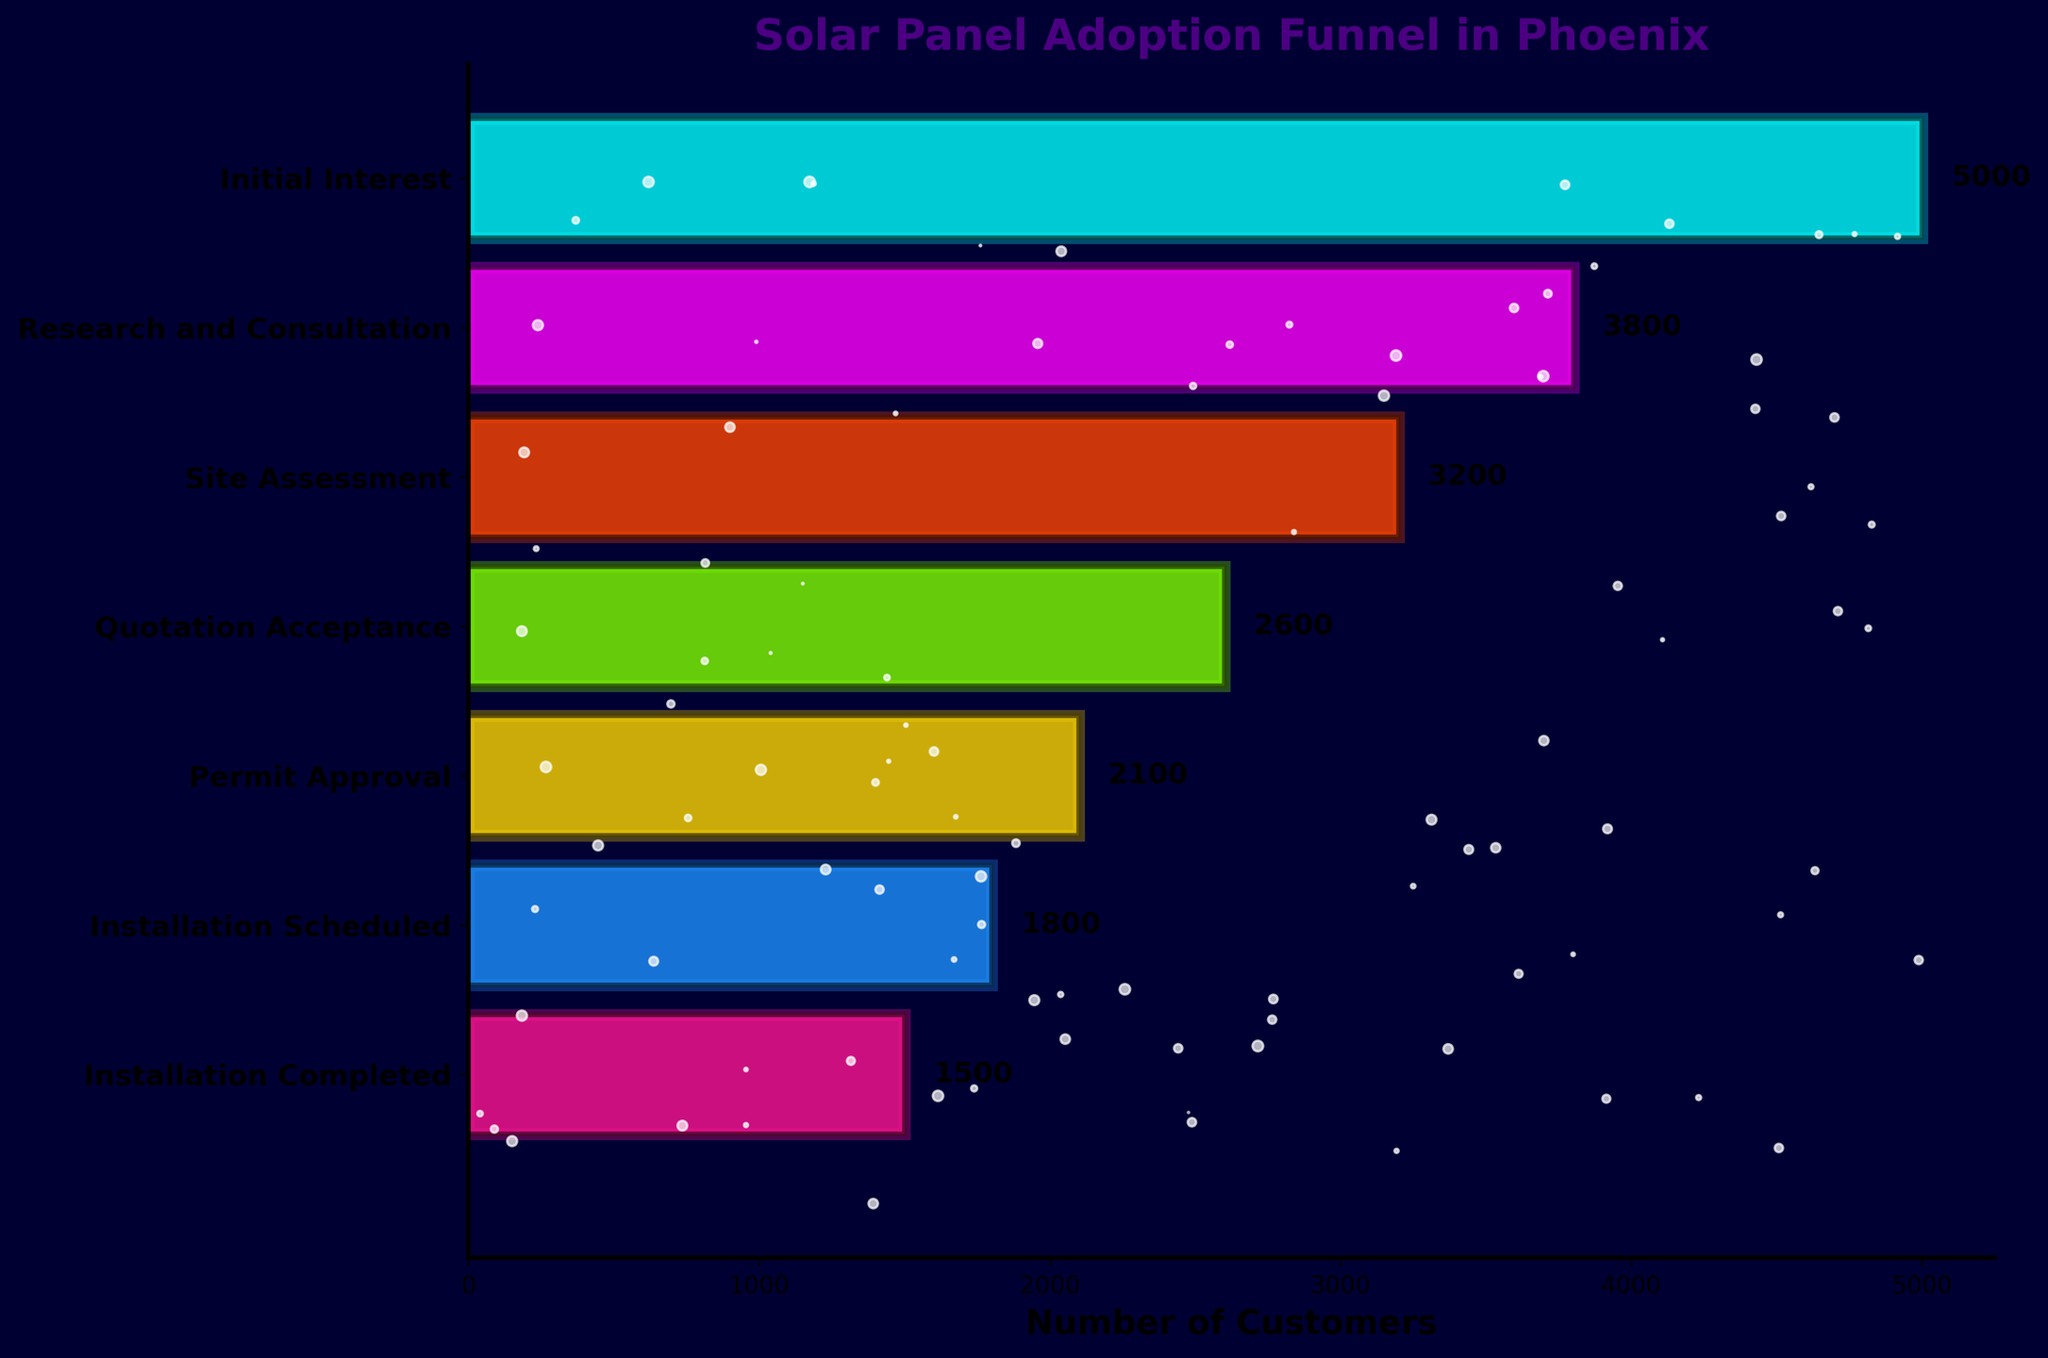What is the title of the chart? The title is located at the top of the chart and provides an overview of the data being represented.
Answer: Solar Panel Adoption Funnel in Phoenix How many stages are there in the funnel chart? Count the number of stages listed on the vertical axis from top to bottom.
Answer: 7 Which stage has the highest number of customers? Identify the longest bar, as it represents the highest count.
Answer: Initial Interest How many more customers are there at the Initial Interest stage compared to the Installation Completed stage? Subtract the number of customers at the Installation Completed stage (1500) from the number at the Initial Interest stage (5000).
Answer: 3500 What is the difference in the number of customers between the Research and Consultation stage and the Permit Approval stage? Subtract the number of customers at the Permit Approval stage (2100) from the number at the Research and Consultation stage (3800).
Answer: 1700 Which stage comes immediately after the Site Assessment stage? Identify the stage listed directly below Site Assessment on the vertical axis.
Answer: Quotation Acceptance By how much does the customer count decrease from the Quotation Acceptance stage to the Installation Scheduled stage? Subtract the number of customers at the Installation Scheduled stage (1800) from the number at the Quotation Acceptance stage (2600).
Answer: 800 What stage has the closest number of customers to the average number of customers across all stages? First, calculate the average number of customers: (5000 + 3800 + 3200 + 2600 + 2100 + 1800 + 1500) / 7 ≈ 2857. Then, compare this with each stage’s customer count. The closest is the Quotation Acceptance stage with 2600.
Answer: Quotation Acceptance Which stage sees the biggest drop in customer numbers compared to the previous stage? Calculate the differences in customer counts between each sequential pair of stages and identify the largest difference: Initial Interest to Research and Consultation (1200), Research and Consultation to Site Assessment (600), Site Assessment to Quotation Acceptance (600), Quotation Acceptance to Permit Approval (500), Permit Approval to Installation Scheduled (300), Installation Scheduled to Installation Completed (300). The biggest drop is from Initial Interest to Research and Consultation.
Answer: Initial Interest to Research and Consultation At how many stages do fewer than 2000 customers remain? Identify and count the stages whose bars represent fewer than 2000 customers: Permit Approval, Installation Scheduled, Installation Completed.
Answer: 3 